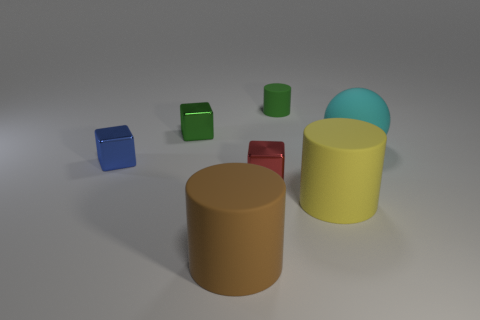Add 3 tiny red cubes. How many objects exist? 10 Subtract all spheres. How many objects are left? 6 Add 1 big yellow cylinders. How many big yellow cylinders are left? 2 Add 4 small red blocks. How many small red blocks exist? 5 Subtract 0 purple cylinders. How many objects are left? 7 Subtract all tiny blocks. Subtract all small yellow cylinders. How many objects are left? 4 